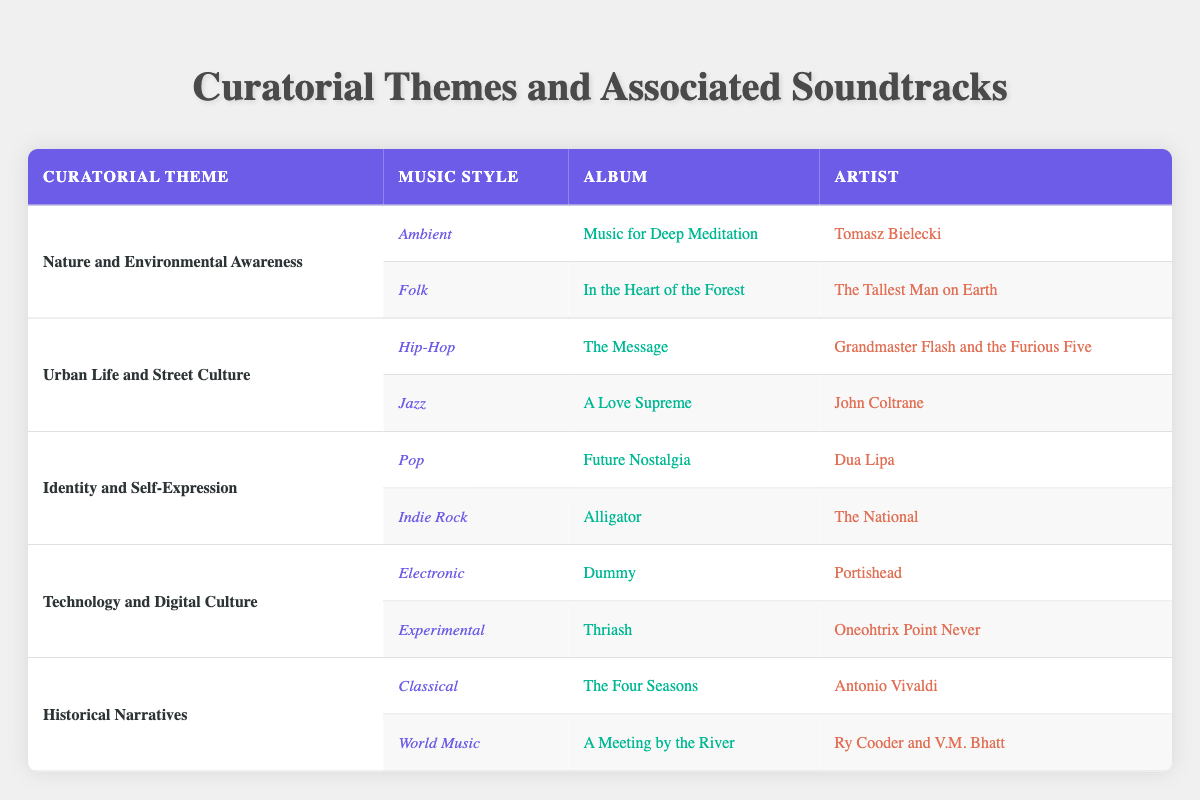What music style is associated with the theme "Nature and Environmental Awareness"? The table lists the music styles associated with each curatorial theme. For the theme "Nature and Environmental Awareness," the music styles are Ambient and Folk.
Answer: Ambient, Folk Which artist created the album "Future Nostalgia"? Looking at the theme "Identity and Self-Expression," we see that the album "Future Nostalgia" is associated with the Pop music style, and the artist is Dua Lipa.
Answer: Dua Lipa Is there a World Music soundtrack associated with the theme "Historical Narratives"? The table indicates that the theme "Historical Narratives" indeed features the World Music style, along with Classical as its other music style.
Answer: Yes How many themes have an associated soundtrack of the music style "Electronic"? The table shows that "Technology and Digital Culture" is the only theme associated with the music style "Electronic," which has one corresponding soundtrack.
Answer: 1 Which album by John Coltrane is related to the theme "Urban Life and Street Culture"? From the theme "Urban Life and Street Culture," the table reveals that the Jazz music style is represented by the album "A Love Supreme," which is created by John Coltrane.
Answer: A Love Supreme What is the combined total of music styles listed for the themes related to identity and self-expression and urban life? Examining both the "Identity and Self-Expression" and "Urban Life and Street Culture" themes, each has two music styles. So, the total count of music styles is 2 (from Identity and Self-Expression) + 2 (from Urban Life and Street Culture) = 4.
Answer: 4 Are there any soundtracks related to the music style "Experimental"? Upon checking the themes, the table lists "Experimental" as a music style under the theme "Technology and Digital Culture," confirming its presence.
Answer: Yes Which theme has the most diverse music styles? By analyzing the themes, "Nature and Environmental Awareness," "Identity and Self-Expression," "Urban Life and Street Culture," "Technology and Digital Culture," and "Historical Narratives," all have two styles, so they are equally diverse in this respect.
Answer: All themes have equal diversity 